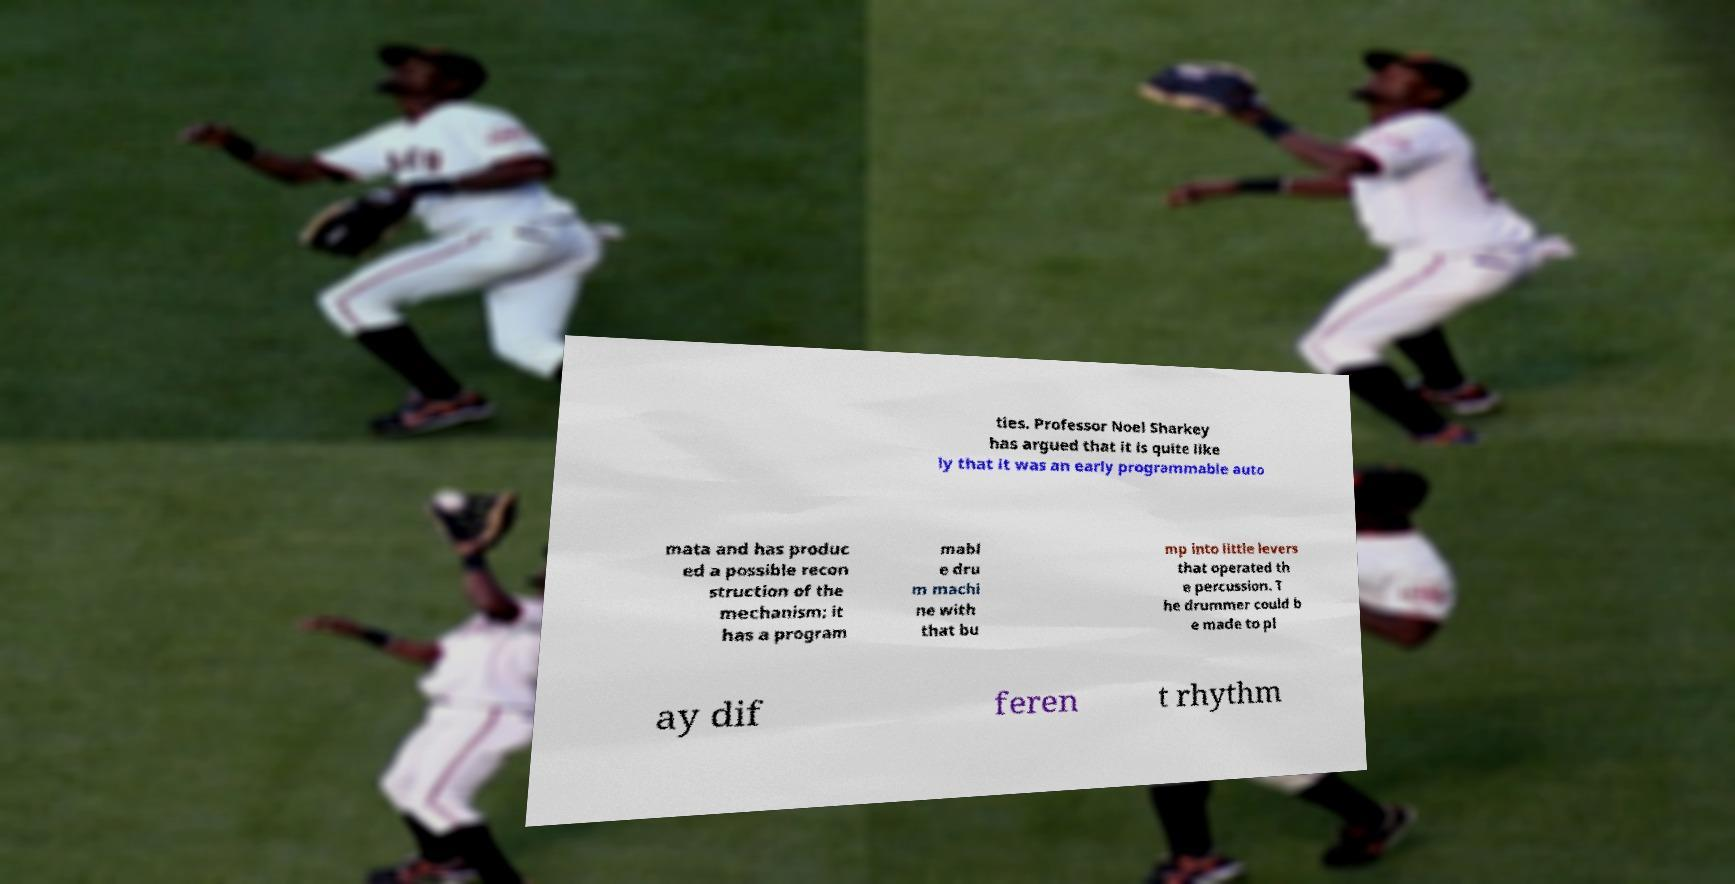What messages or text are displayed in this image? I need them in a readable, typed format. ties. Professor Noel Sharkey has argued that it is quite like ly that it was an early programmable auto mata and has produc ed a possible recon struction of the mechanism; it has a program mabl e dru m machi ne with that bu mp into little levers that operated th e percussion. T he drummer could b e made to pl ay dif feren t rhythm 